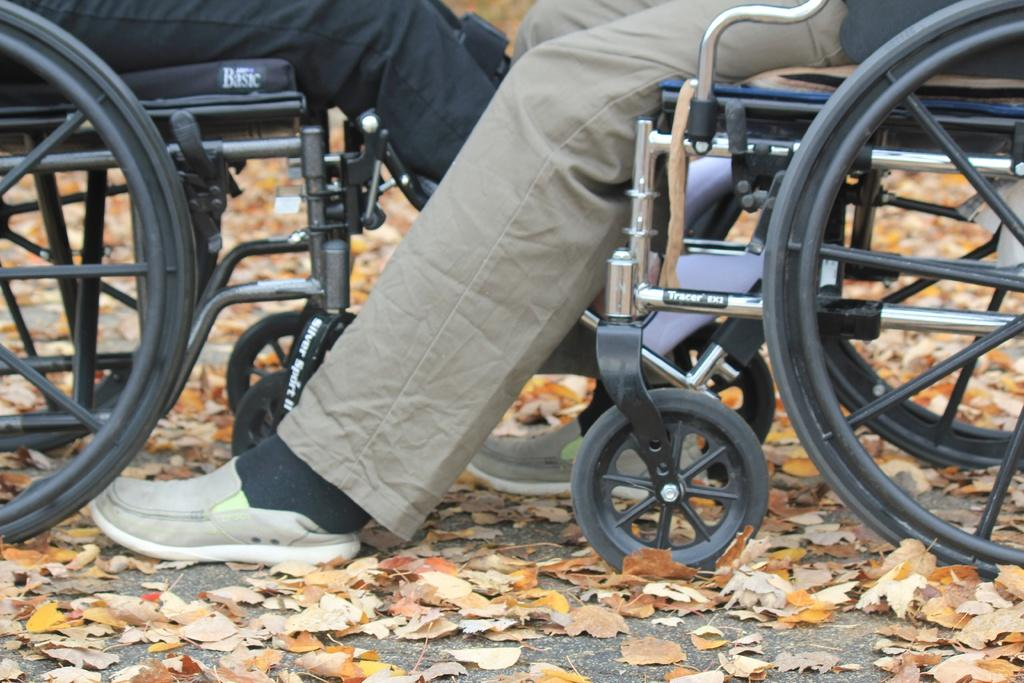What are the people in the image using to move around? The people in the image are sitting on wheelchairs. What can be seen on the ground in the image? There are many leaves on the ground in the image. How many wheelchairs are visible in the image? There are two wheelchairs in the image. What color is the tongue of the person sitting on the wheelchair in the image? There is no tongue visible in the image, as the people are sitting on wheelchairs and their faces are not shown. 